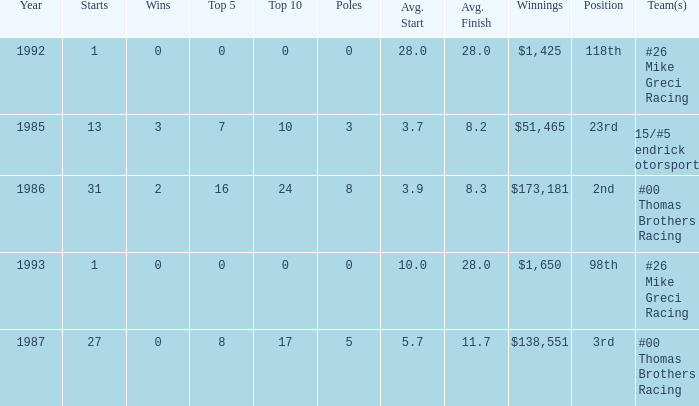What was the average finish the year Bodine finished 3rd? 11.7. 